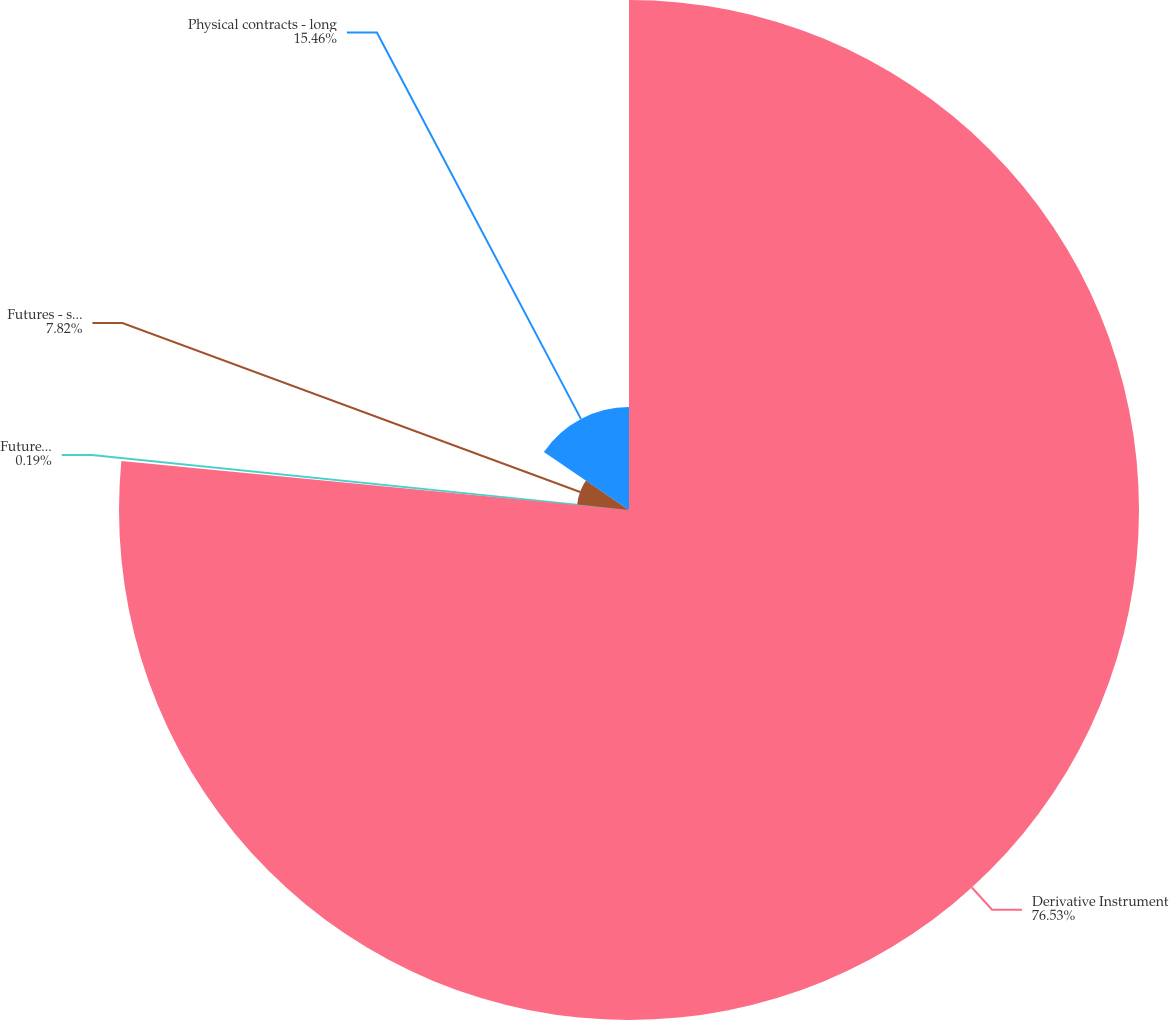Convert chart to OTSL. <chart><loc_0><loc_0><loc_500><loc_500><pie_chart><fcel>Derivative Instrument<fcel>Futures - long<fcel>Futures - short<fcel>Physical contracts - long<nl><fcel>76.53%<fcel>0.19%<fcel>7.82%<fcel>15.46%<nl></chart> 